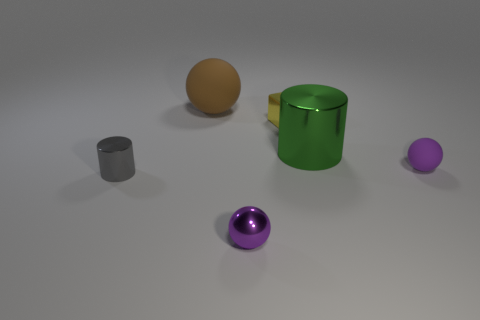Subtract all purple metallic spheres. How many spheres are left? 2 Subtract all cyan cylinders. How many purple balls are left? 2 Add 1 tiny blue metallic blocks. How many objects exist? 7 Subtract all cylinders. How many objects are left? 4 Subtract 1 spheres. How many spheres are left? 2 Subtract all brown spheres. How many spheres are left? 2 Subtract all small cylinders. Subtract all small purple matte balls. How many objects are left? 4 Add 4 large metallic objects. How many large metallic objects are left? 5 Add 5 small blue shiny balls. How many small blue shiny balls exist? 5 Subtract 0 blue spheres. How many objects are left? 6 